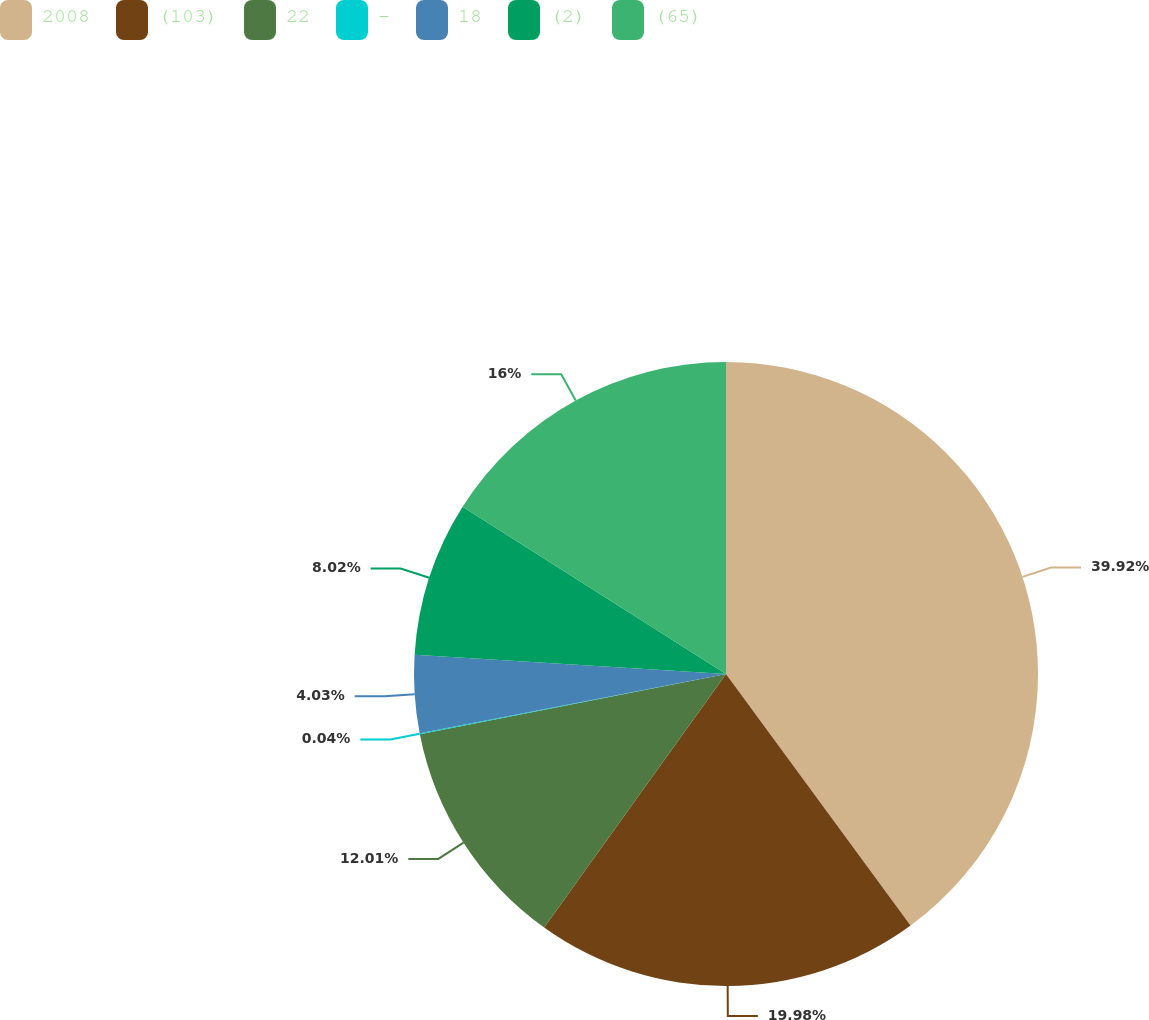<chart> <loc_0><loc_0><loc_500><loc_500><pie_chart><fcel>2008<fcel>(103)<fcel>22<fcel>-<fcel>18<fcel>(2)<fcel>(65)<nl><fcel>39.93%<fcel>19.98%<fcel>12.01%<fcel>0.04%<fcel>4.03%<fcel>8.02%<fcel>16.0%<nl></chart> 